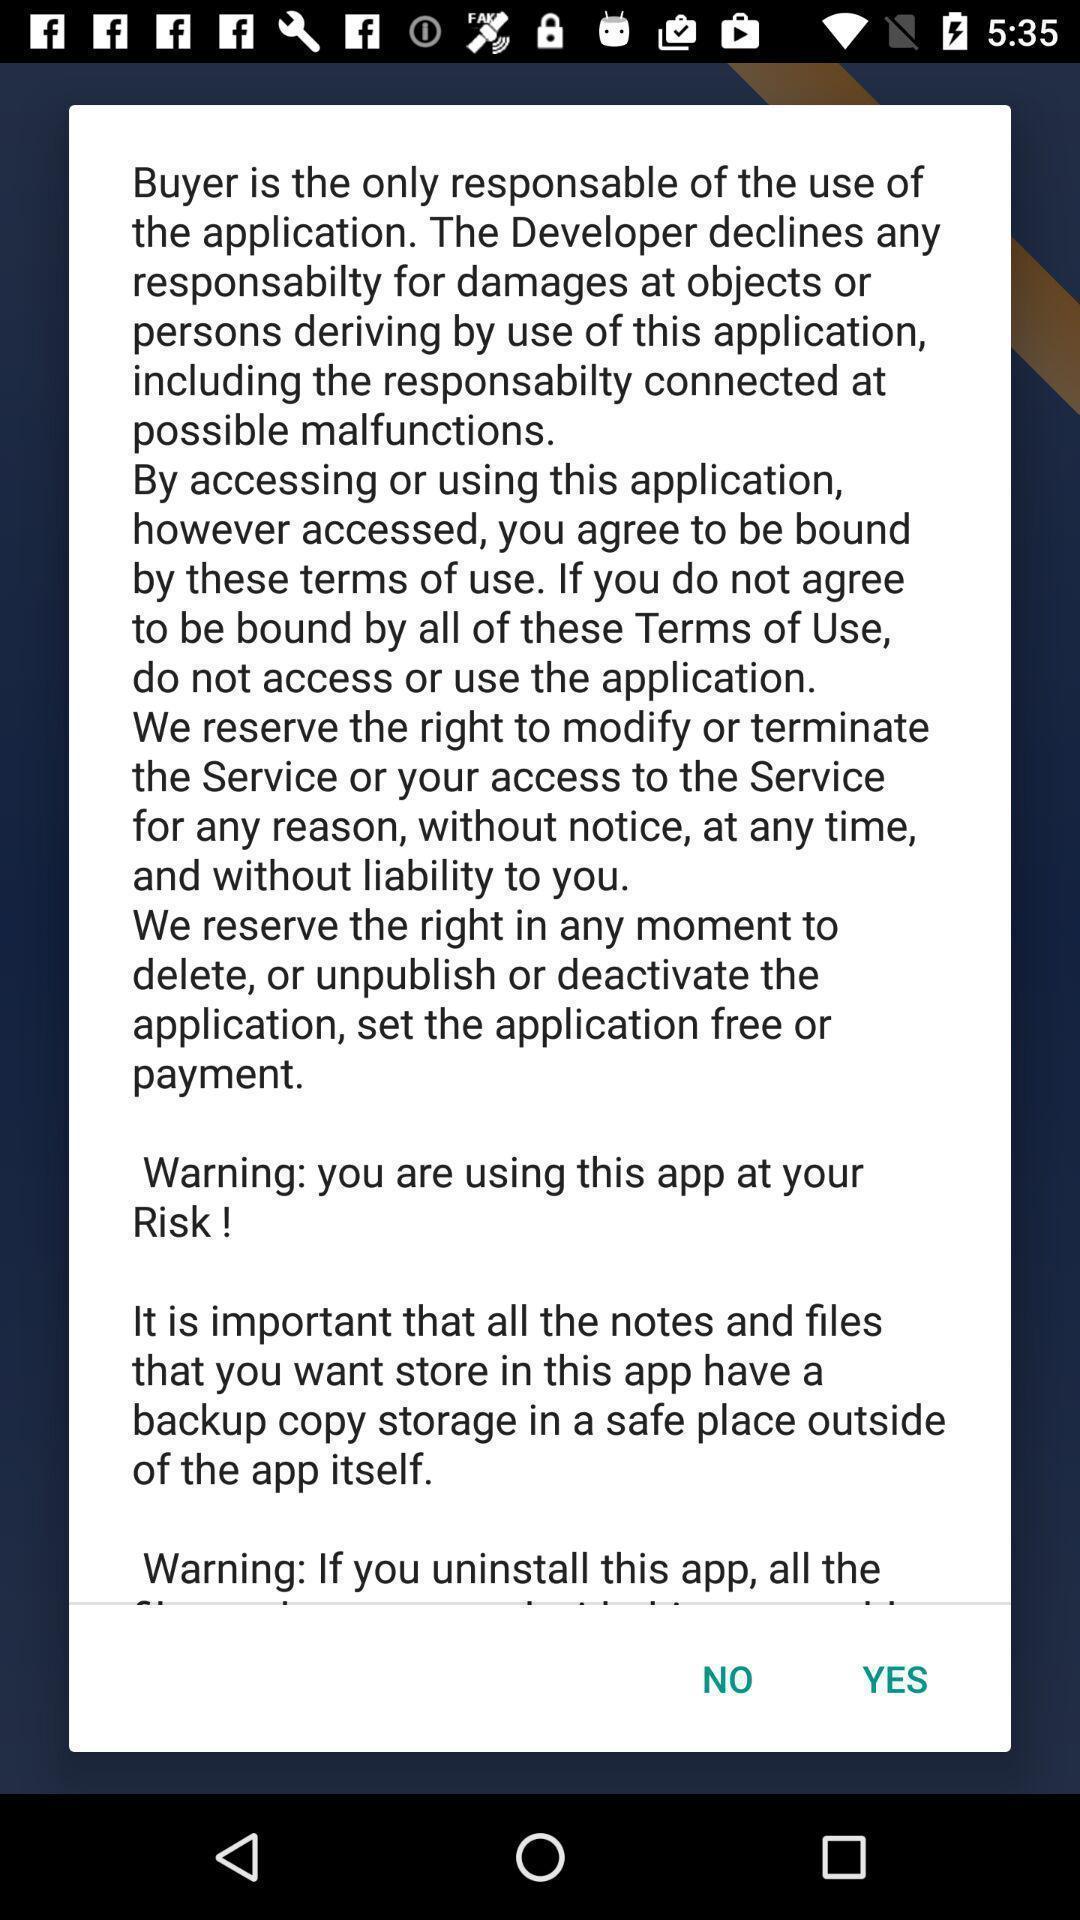What is the overall content of this screenshot? Pop-up showing the terms and conditions. 